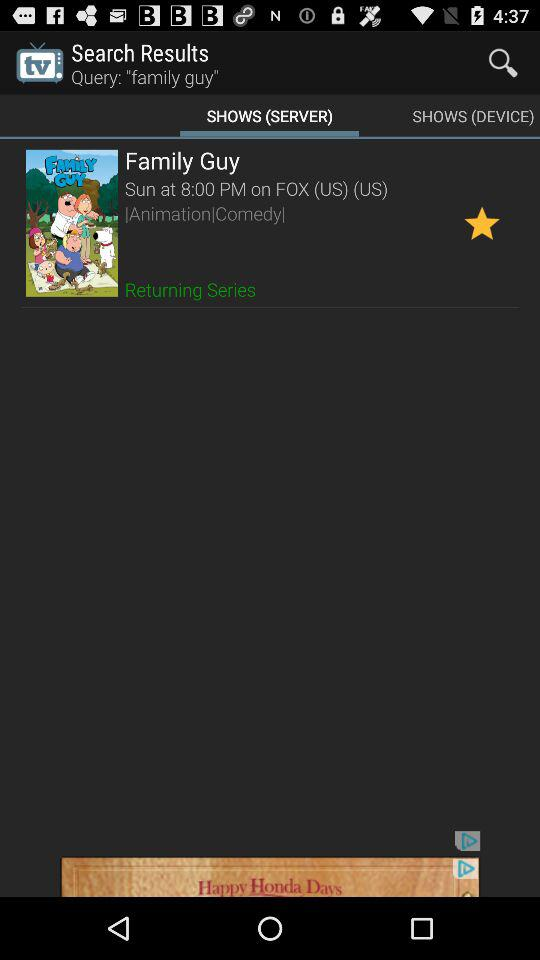What time will the Family Guy show telecast? The Family Guy show will telecast at 8:00 a.m. 